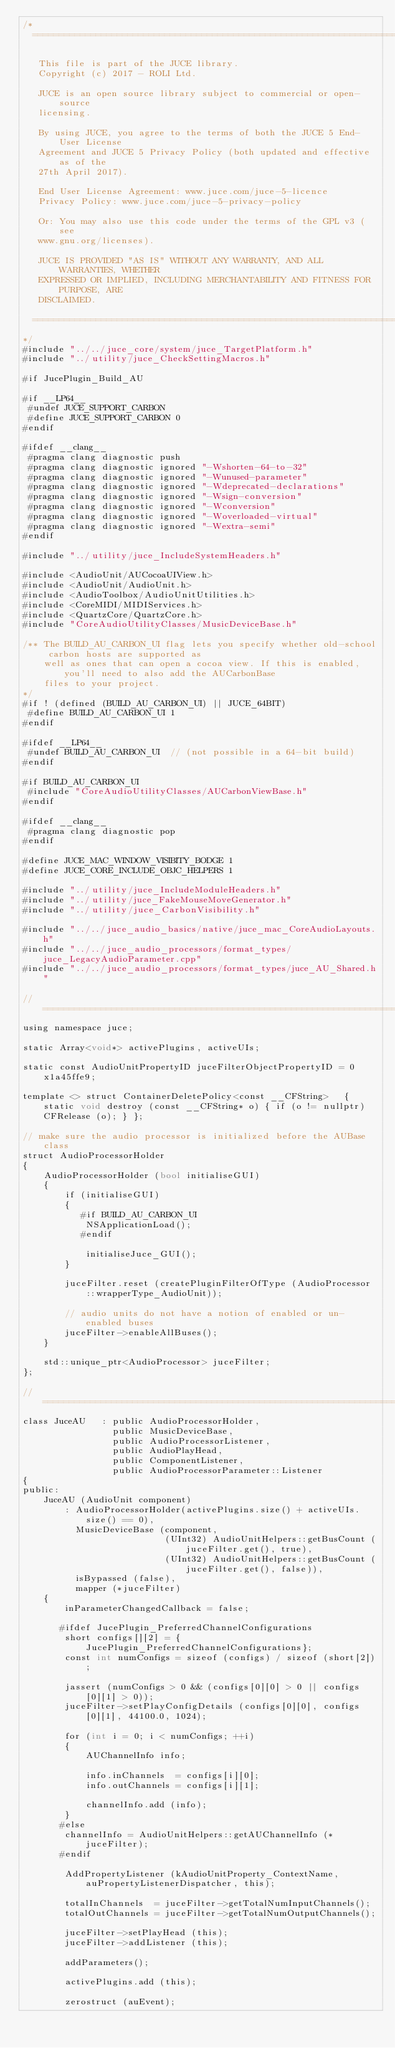<code> <loc_0><loc_0><loc_500><loc_500><_ObjectiveC_>/*
  ==============================================================================

   This file is part of the JUCE library.
   Copyright (c) 2017 - ROLI Ltd.

   JUCE is an open source library subject to commercial or open-source
   licensing.

   By using JUCE, you agree to the terms of both the JUCE 5 End-User License
   Agreement and JUCE 5 Privacy Policy (both updated and effective as of the
   27th April 2017).

   End User License Agreement: www.juce.com/juce-5-licence
   Privacy Policy: www.juce.com/juce-5-privacy-policy

   Or: You may also use this code under the terms of the GPL v3 (see
   www.gnu.org/licenses).

   JUCE IS PROVIDED "AS IS" WITHOUT ANY WARRANTY, AND ALL WARRANTIES, WHETHER
   EXPRESSED OR IMPLIED, INCLUDING MERCHANTABILITY AND FITNESS FOR PURPOSE, ARE
   DISCLAIMED.

  ==============================================================================
*/
#include "../../juce_core/system/juce_TargetPlatform.h"
#include "../utility/juce_CheckSettingMacros.h"

#if JucePlugin_Build_AU

#if __LP64__
 #undef JUCE_SUPPORT_CARBON
 #define JUCE_SUPPORT_CARBON 0
#endif

#ifdef __clang__
 #pragma clang diagnostic push
 #pragma clang diagnostic ignored "-Wshorten-64-to-32"
 #pragma clang diagnostic ignored "-Wunused-parameter"
 #pragma clang diagnostic ignored "-Wdeprecated-declarations"
 #pragma clang diagnostic ignored "-Wsign-conversion"
 #pragma clang diagnostic ignored "-Wconversion"
 #pragma clang diagnostic ignored "-Woverloaded-virtual"
 #pragma clang diagnostic ignored "-Wextra-semi"
#endif

#include "../utility/juce_IncludeSystemHeaders.h"

#include <AudioUnit/AUCocoaUIView.h>
#include <AudioUnit/AudioUnit.h>
#include <AudioToolbox/AudioUnitUtilities.h>
#include <CoreMIDI/MIDIServices.h>
#include <QuartzCore/QuartzCore.h>
#include "CoreAudioUtilityClasses/MusicDeviceBase.h"

/** The BUILD_AU_CARBON_UI flag lets you specify whether old-school carbon hosts are supported as
    well as ones that can open a cocoa view. If this is enabled, you'll need to also add the AUCarbonBase
    files to your project.
*/
#if ! (defined (BUILD_AU_CARBON_UI) || JUCE_64BIT)
 #define BUILD_AU_CARBON_UI 1
#endif

#ifdef __LP64__
 #undef BUILD_AU_CARBON_UI  // (not possible in a 64-bit build)
#endif

#if BUILD_AU_CARBON_UI
 #include "CoreAudioUtilityClasses/AUCarbonViewBase.h"
#endif

#ifdef __clang__
 #pragma clang diagnostic pop
#endif

#define JUCE_MAC_WINDOW_VISIBITY_BODGE 1
#define JUCE_CORE_INCLUDE_OBJC_HELPERS 1

#include "../utility/juce_IncludeModuleHeaders.h"
#include "../utility/juce_FakeMouseMoveGenerator.h"
#include "../utility/juce_CarbonVisibility.h"

#include "../../juce_audio_basics/native/juce_mac_CoreAudioLayouts.h"
#include "../../juce_audio_processors/format_types/juce_LegacyAudioParameter.cpp"
#include "../../juce_audio_processors/format_types/juce_AU_Shared.h"

//==============================================================================
using namespace juce;

static Array<void*> activePlugins, activeUIs;

static const AudioUnitPropertyID juceFilterObjectPropertyID = 0x1a45ffe9;

template <> struct ContainerDeletePolicy<const __CFString>   { static void destroy (const __CFString* o) { if (o != nullptr) CFRelease (o); } };

// make sure the audio processor is initialized before the AUBase class
struct AudioProcessorHolder
{
    AudioProcessorHolder (bool initialiseGUI)
    {
        if (initialiseGUI)
        {
           #if BUILD_AU_CARBON_UI
            NSApplicationLoad();
           #endif

            initialiseJuce_GUI();
        }

        juceFilter.reset (createPluginFilterOfType (AudioProcessor::wrapperType_AudioUnit));

        // audio units do not have a notion of enabled or un-enabled buses
        juceFilter->enableAllBuses();
    }

    std::unique_ptr<AudioProcessor> juceFilter;
};

//==============================================================================
class JuceAU   : public AudioProcessorHolder,
                 public MusicDeviceBase,
                 public AudioProcessorListener,
                 public AudioPlayHead,
                 public ComponentListener,
                 public AudioProcessorParameter::Listener
{
public:
    JuceAU (AudioUnit component)
        : AudioProcessorHolder(activePlugins.size() + activeUIs.size() == 0),
          MusicDeviceBase (component,
                           (UInt32) AudioUnitHelpers::getBusCount (juceFilter.get(), true),
                           (UInt32) AudioUnitHelpers::getBusCount (juceFilter.get(), false)),
          isBypassed (false),
          mapper (*juceFilter)
    {
        inParameterChangedCallback = false;

       #ifdef JucePlugin_PreferredChannelConfigurations
        short configs[][2] = {JucePlugin_PreferredChannelConfigurations};
        const int numConfigs = sizeof (configs) / sizeof (short[2]);

        jassert (numConfigs > 0 && (configs[0][0] > 0 || configs[0][1] > 0));
        juceFilter->setPlayConfigDetails (configs[0][0], configs[0][1], 44100.0, 1024);

        for (int i = 0; i < numConfigs; ++i)
        {
            AUChannelInfo info;

            info.inChannels  = configs[i][0];
            info.outChannels = configs[i][1];

            channelInfo.add (info);
        }
       #else
        channelInfo = AudioUnitHelpers::getAUChannelInfo (*juceFilter);
       #endif

        AddPropertyListener (kAudioUnitProperty_ContextName, auPropertyListenerDispatcher, this);

        totalInChannels  = juceFilter->getTotalNumInputChannels();
        totalOutChannels = juceFilter->getTotalNumOutputChannels();

        juceFilter->setPlayHead (this);
        juceFilter->addListener (this);

        addParameters();

        activePlugins.add (this);

        zerostruct (auEvent);</code> 